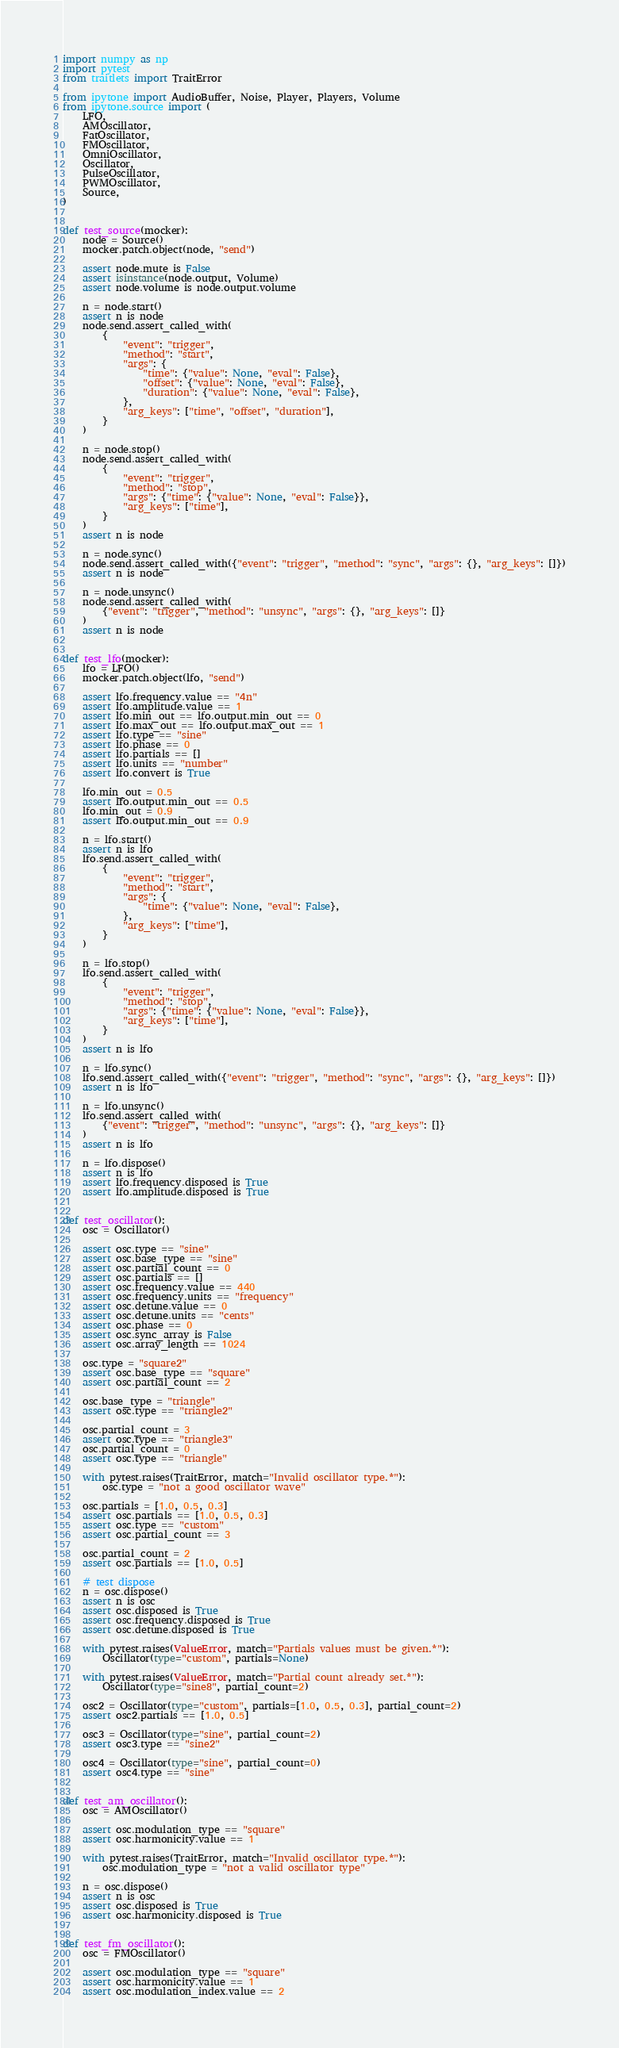Convert code to text. <code><loc_0><loc_0><loc_500><loc_500><_Python_>import numpy as np
import pytest
from traitlets import TraitError

from ipytone import AudioBuffer, Noise, Player, Players, Volume
from ipytone.source import (
    LFO,
    AMOscillator,
    FatOscillator,
    FMOscillator,
    OmniOscillator,
    Oscillator,
    PulseOscillator,
    PWMOscillator,
    Source,
)


def test_source(mocker):
    node = Source()
    mocker.patch.object(node, "send")

    assert node.mute is False
    assert isinstance(node.output, Volume)
    assert node.volume is node.output.volume

    n = node.start()
    assert n is node
    node.send.assert_called_with(
        {
            "event": "trigger",
            "method": "start",
            "args": {
                "time": {"value": None, "eval": False},
                "offset": {"value": None, "eval": False},
                "duration": {"value": None, "eval": False},
            },
            "arg_keys": ["time", "offset", "duration"],
        }
    )

    n = node.stop()
    node.send.assert_called_with(
        {
            "event": "trigger",
            "method": "stop",
            "args": {"time": {"value": None, "eval": False}},
            "arg_keys": ["time"],
        }
    )
    assert n is node

    n = node.sync()
    node.send.assert_called_with({"event": "trigger", "method": "sync", "args": {}, "arg_keys": []})
    assert n is node

    n = node.unsync()
    node.send.assert_called_with(
        {"event": "trigger", "method": "unsync", "args": {}, "arg_keys": []}
    )
    assert n is node


def test_lfo(mocker):
    lfo = LFO()
    mocker.patch.object(lfo, "send")

    assert lfo.frequency.value == "4n"
    assert lfo.amplitude.value == 1
    assert lfo.min_out == lfo.output.min_out == 0
    assert lfo.max_out == lfo.output.max_out == 1
    assert lfo.type == "sine"
    assert lfo.phase == 0
    assert lfo.partials == []
    assert lfo.units == "number"
    assert lfo.convert is True

    lfo.min_out = 0.5
    assert lfo.output.min_out == 0.5
    lfo.min_out = 0.9
    assert lfo.output.min_out == 0.9

    n = lfo.start()
    assert n is lfo
    lfo.send.assert_called_with(
        {
            "event": "trigger",
            "method": "start",
            "args": {
                "time": {"value": None, "eval": False},
            },
            "arg_keys": ["time"],
        }
    )

    n = lfo.stop()
    lfo.send.assert_called_with(
        {
            "event": "trigger",
            "method": "stop",
            "args": {"time": {"value": None, "eval": False}},
            "arg_keys": ["time"],
        }
    )
    assert n is lfo

    n = lfo.sync()
    lfo.send.assert_called_with({"event": "trigger", "method": "sync", "args": {}, "arg_keys": []})
    assert n is lfo

    n = lfo.unsync()
    lfo.send.assert_called_with(
        {"event": "trigger", "method": "unsync", "args": {}, "arg_keys": []}
    )
    assert n is lfo

    n = lfo.dispose()
    assert n is lfo
    assert lfo.frequency.disposed is True
    assert lfo.amplitude.disposed is True


def test_oscillator():
    osc = Oscillator()

    assert osc.type == "sine"
    assert osc.base_type == "sine"
    assert osc.partial_count == 0
    assert osc.partials == []
    assert osc.frequency.value == 440
    assert osc.frequency.units == "frequency"
    assert osc.detune.value == 0
    assert osc.detune.units == "cents"
    assert osc.phase == 0
    assert osc.sync_array is False
    assert osc.array_length == 1024

    osc.type = "square2"
    assert osc.base_type == "square"
    assert osc.partial_count == 2

    osc.base_type = "triangle"
    assert osc.type == "triangle2"

    osc.partial_count = 3
    assert osc.type == "triangle3"
    osc.partial_count = 0
    assert osc.type == "triangle"

    with pytest.raises(TraitError, match="Invalid oscillator type.*"):
        osc.type = "not a good oscillator wave"

    osc.partials = [1.0, 0.5, 0.3]
    assert osc.partials == [1.0, 0.5, 0.3]
    assert osc.type == "custom"
    assert osc.partial_count == 3

    osc.partial_count = 2
    assert osc.partials == [1.0, 0.5]

    # test dispose
    n = osc.dispose()
    assert n is osc
    assert osc.disposed is True
    assert osc.frequency.disposed is True
    assert osc.detune.disposed is True

    with pytest.raises(ValueError, match="Partials values must be given.*"):
        Oscillator(type="custom", partials=None)

    with pytest.raises(ValueError, match="Partial count already set.*"):
        Oscillator(type="sine8", partial_count=2)

    osc2 = Oscillator(type="custom", partials=[1.0, 0.5, 0.3], partial_count=2)
    assert osc2.partials == [1.0, 0.5]

    osc3 = Oscillator(type="sine", partial_count=2)
    assert osc3.type == "sine2"

    osc4 = Oscillator(type="sine", partial_count=0)
    assert osc4.type == "sine"


def test_am_oscillator():
    osc = AMOscillator()

    assert osc.modulation_type == "square"
    assert osc.harmonicity.value == 1

    with pytest.raises(TraitError, match="Invalid oscillator type.*"):
        osc.modulation_type = "not a valid oscillator type"

    n = osc.dispose()
    assert n is osc
    assert osc.disposed is True
    assert osc.harmonicity.disposed is True


def test_fm_oscillator():
    osc = FMOscillator()

    assert osc.modulation_type == "square"
    assert osc.harmonicity.value == 1
    assert osc.modulation_index.value == 2
</code> 